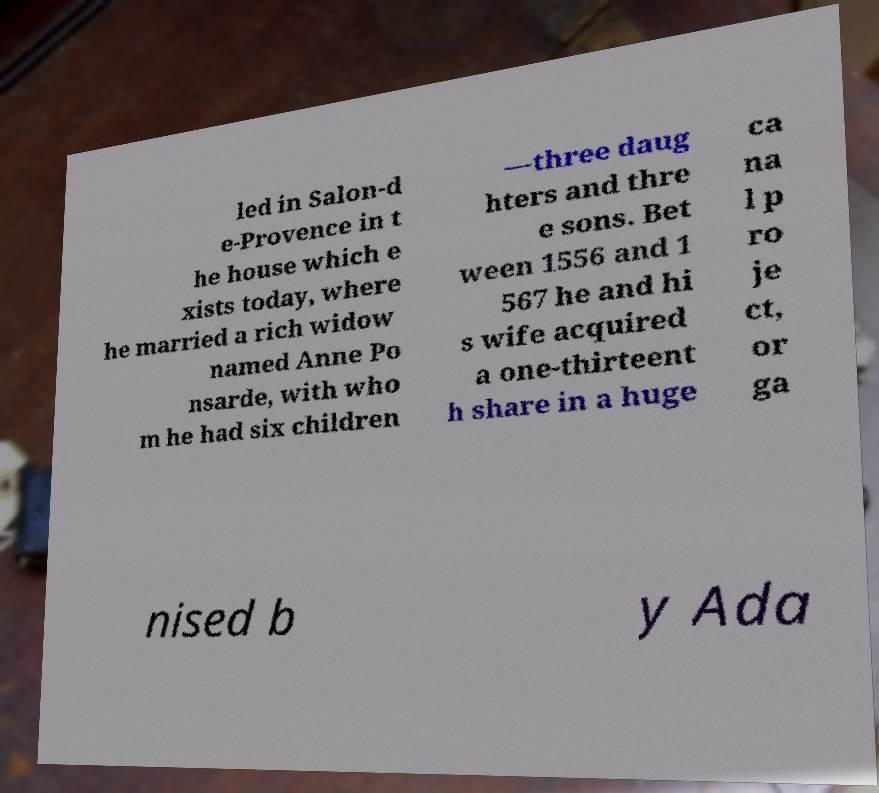For documentation purposes, I need the text within this image transcribed. Could you provide that? led in Salon-d e-Provence in t he house which e xists today, where he married a rich widow named Anne Po nsarde, with who m he had six children —three daug hters and thre e sons. Bet ween 1556 and 1 567 he and hi s wife acquired a one-thirteent h share in a huge ca na l p ro je ct, or ga nised b y Ada 